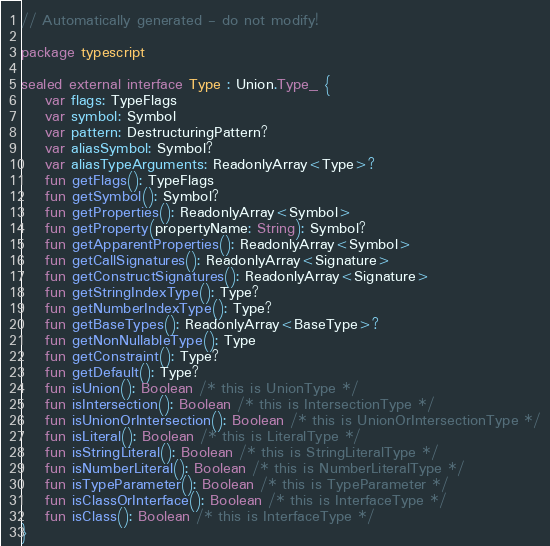<code> <loc_0><loc_0><loc_500><loc_500><_Kotlin_>// Automatically generated - do not modify!

package typescript

sealed external interface Type : Union.Type_ {
    var flags: TypeFlags
    var symbol: Symbol
    var pattern: DestructuringPattern?
    var aliasSymbol: Symbol?
    var aliasTypeArguments: ReadonlyArray<Type>?
    fun getFlags(): TypeFlags
    fun getSymbol(): Symbol?
    fun getProperties(): ReadonlyArray<Symbol>
    fun getProperty(propertyName: String): Symbol?
    fun getApparentProperties(): ReadonlyArray<Symbol>
    fun getCallSignatures(): ReadonlyArray<Signature>
    fun getConstructSignatures(): ReadonlyArray<Signature>
    fun getStringIndexType(): Type?
    fun getNumberIndexType(): Type?
    fun getBaseTypes(): ReadonlyArray<BaseType>?
    fun getNonNullableType(): Type
    fun getConstraint(): Type?
    fun getDefault(): Type?
    fun isUnion(): Boolean /* this is UnionType */
    fun isIntersection(): Boolean /* this is IntersectionType */
    fun isUnionOrIntersection(): Boolean /* this is UnionOrIntersectionType */
    fun isLiteral(): Boolean /* this is LiteralType */
    fun isStringLiteral(): Boolean /* this is StringLiteralType */
    fun isNumberLiteral(): Boolean /* this is NumberLiteralType */
    fun isTypeParameter(): Boolean /* this is TypeParameter */
    fun isClassOrInterface(): Boolean /* this is InterfaceType */
    fun isClass(): Boolean /* this is InterfaceType */
}
</code> 